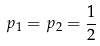<formula> <loc_0><loc_0><loc_500><loc_500>p _ { 1 } = p _ { 2 } = \frac { 1 } { 2 }</formula> 